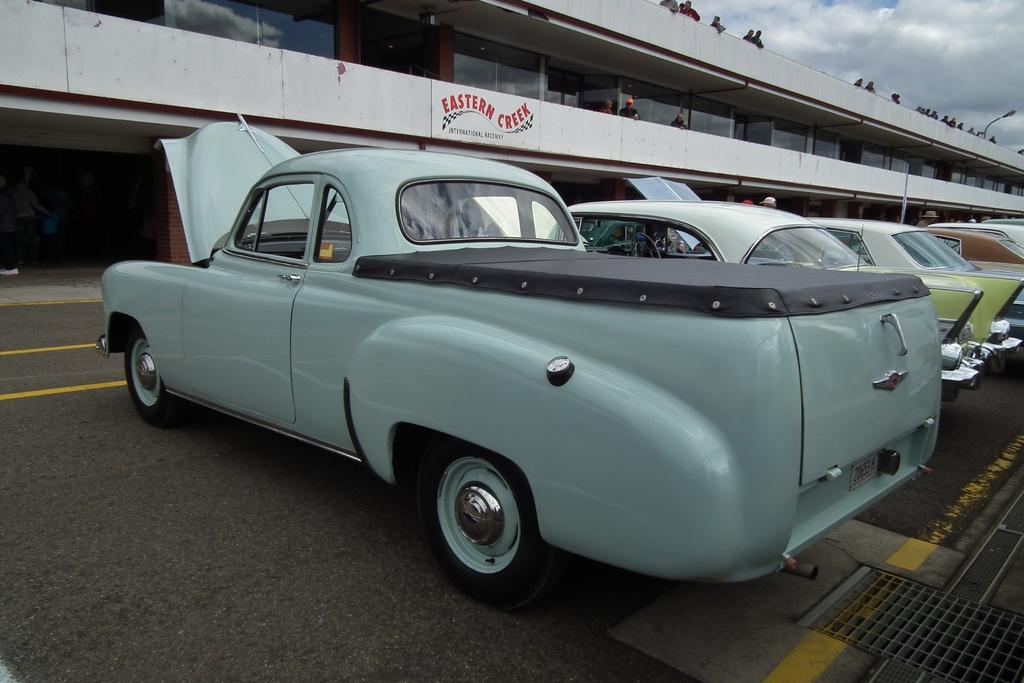What can be seen on the road in the image? There are cars on the road in the image. What is located in the background of the image? There is a building and persons visible in the background of the image. What is visible above the building and persons in the image? The sky is visible in the background of the image. What can be observed in the sky? Clouds are present in the sky. What type of marble is being used to construct the boundary in the image? There is no marble or boundary present in the image. What is the hammer being used for in the image? There is no hammer present in the image. 